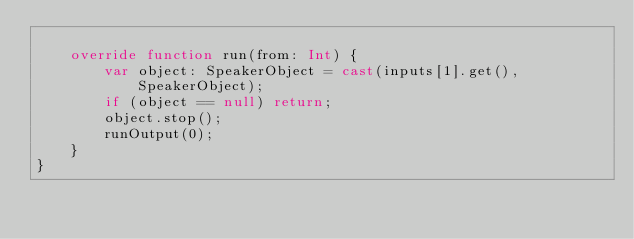<code> <loc_0><loc_0><loc_500><loc_500><_Haxe_>
	override function run(from: Int) {
		var object: SpeakerObject = cast(inputs[1].get(), SpeakerObject);
		if (object == null) return;
		object.stop();
		runOutput(0);
	}
}
</code> 